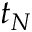<formula> <loc_0><loc_0><loc_500><loc_500>t _ { N }</formula> 